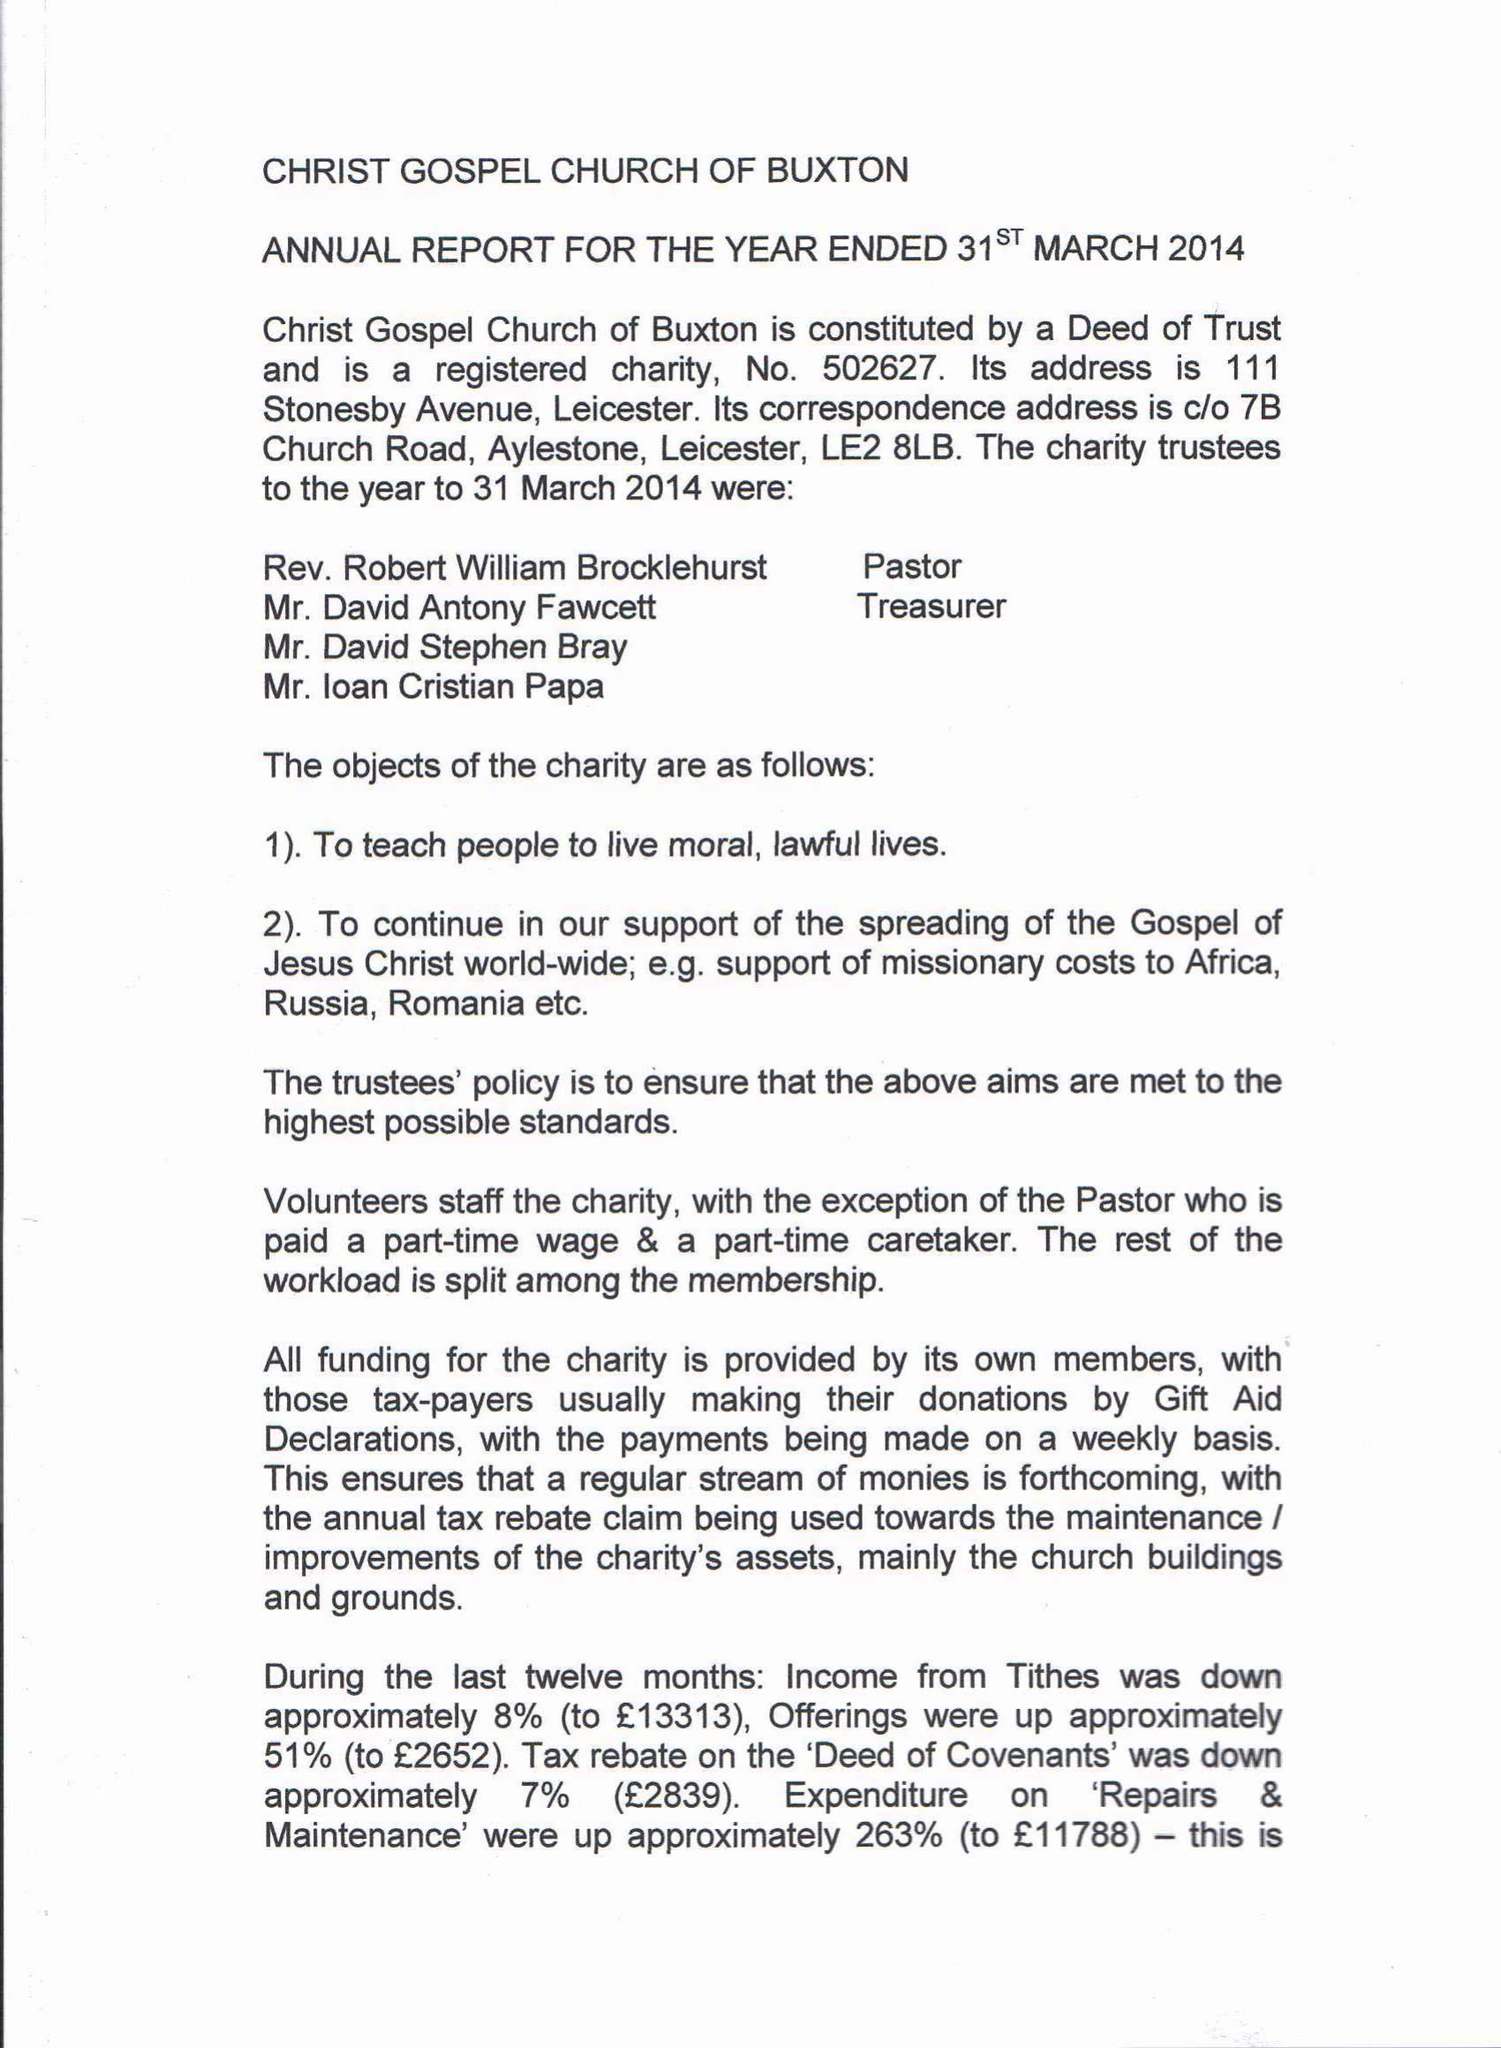What is the value for the income_annually_in_british_pounds?
Answer the question using a single word or phrase. 39163.45 